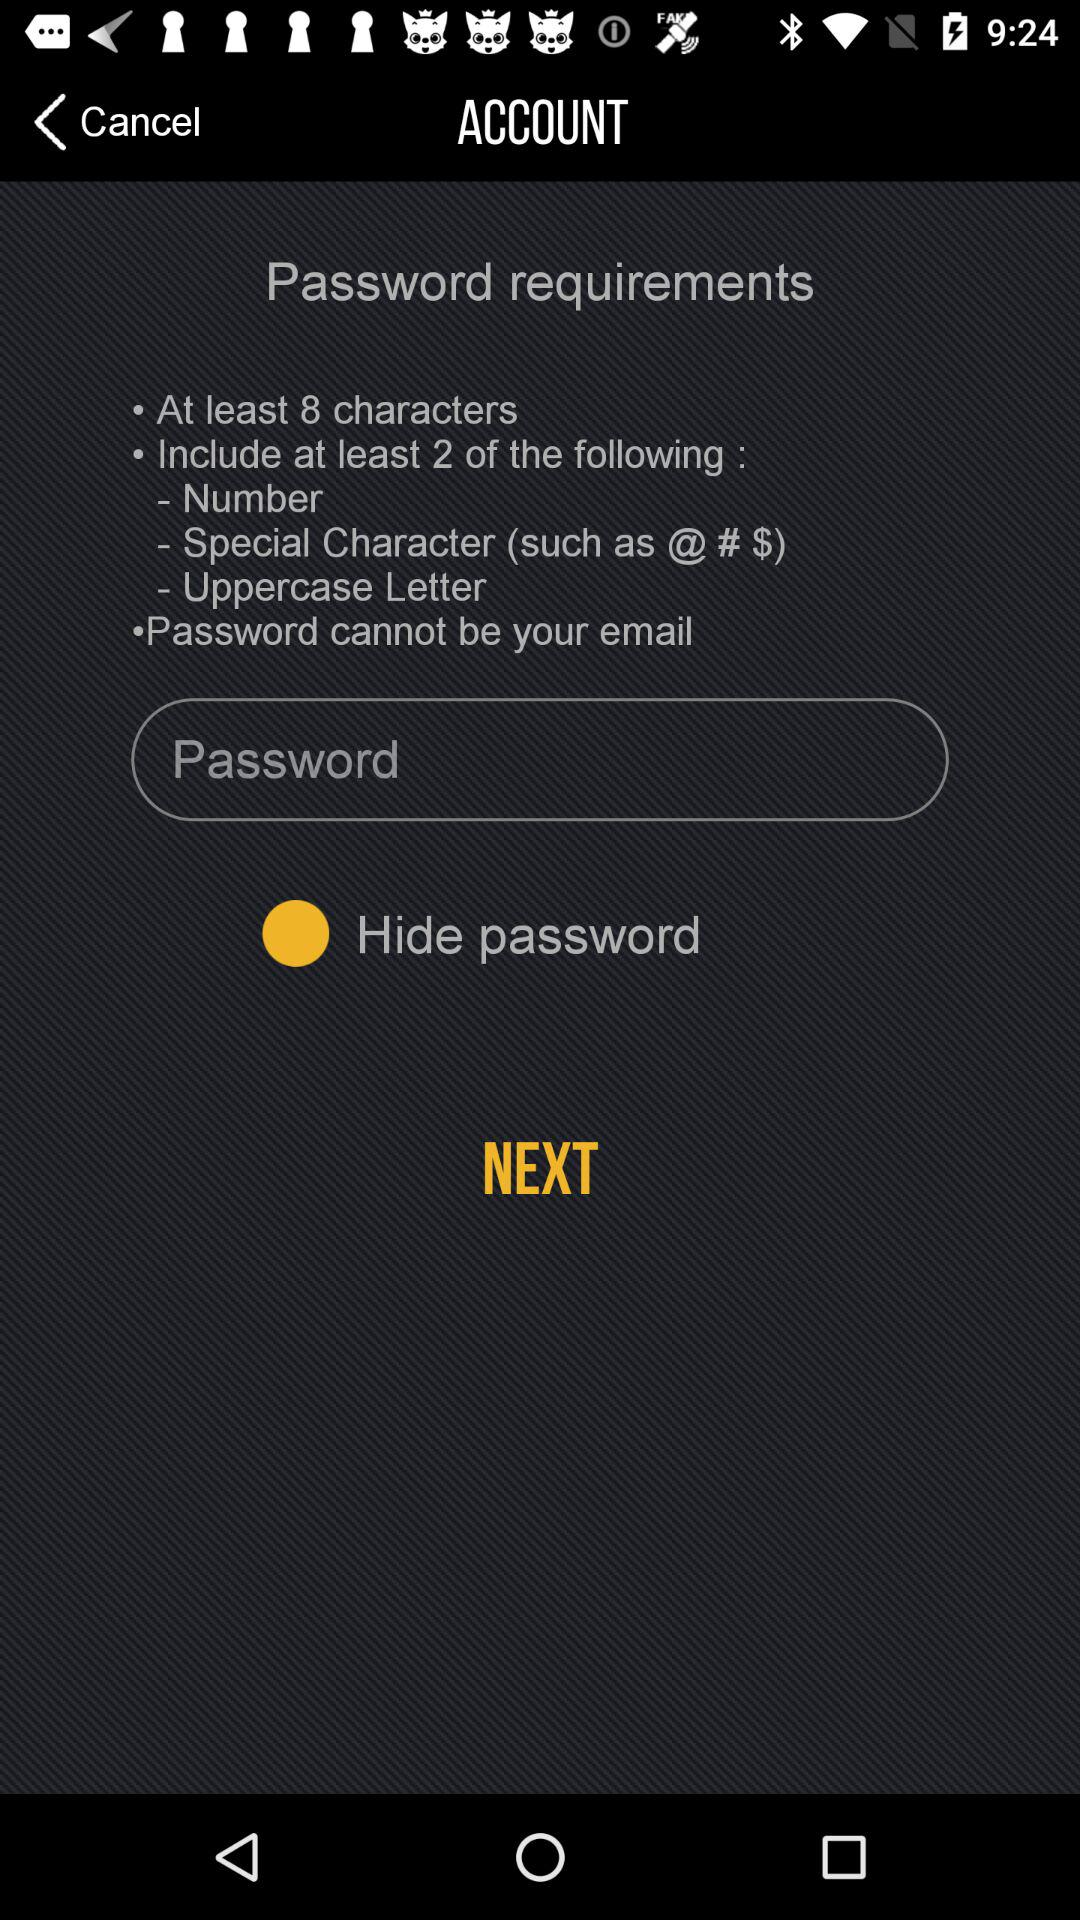How many characters at least does it require? It requires at least 8 characters. 